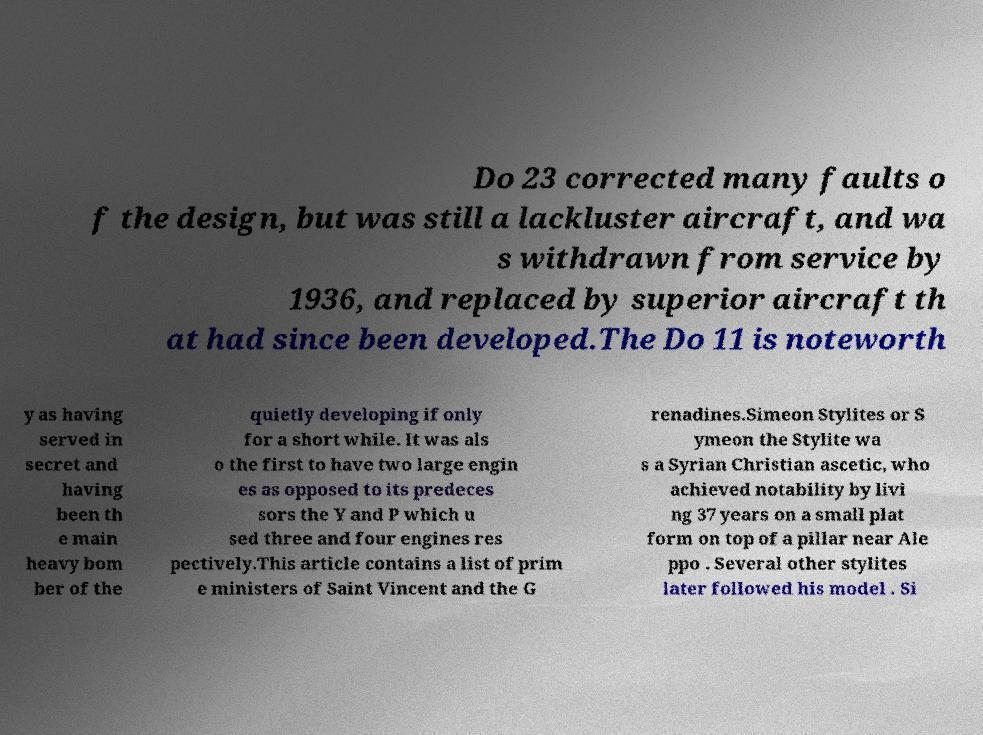What messages or text are displayed in this image? I need them in a readable, typed format. Do 23 corrected many faults o f the design, but was still a lackluster aircraft, and wa s withdrawn from service by 1936, and replaced by superior aircraft th at had since been developed.The Do 11 is noteworth y as having served in secret and having been th e main heavy bom ber of the quietly developing if only for a short while. It was als o the first to have two large engin es as opposed to its predeces sors the Y and P which u sed three and four engines res pectively.This article contains a list of prim e ministers of Saint Vincent and the G renadines.Simeon Stylites or S ymeon the Stylite wa s a Syrian Christian ascetic, who achieved notability by livi ng 37 years on a small plat form on top of a pillar near Ale ppo . Several other stylites later followed his model . Si 